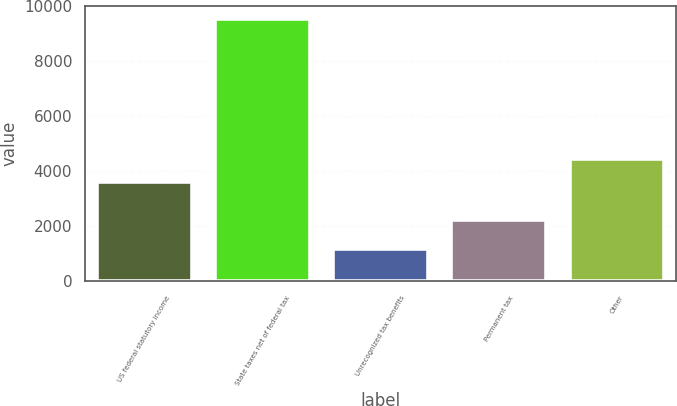Convert chart. <chart><loc_0><loc_0><loc_500><loc_500><bar_chart><fcel>US federal statutory income<fcel>State taxes net of federal tax<fcel>Unrecognized tax benefits<fcel>Permanent tax<fcel>Other<nl><fcel>3608<fcel>9537<fcel>1178<fcel>2246<fcel>4443.9<nl></chart> 